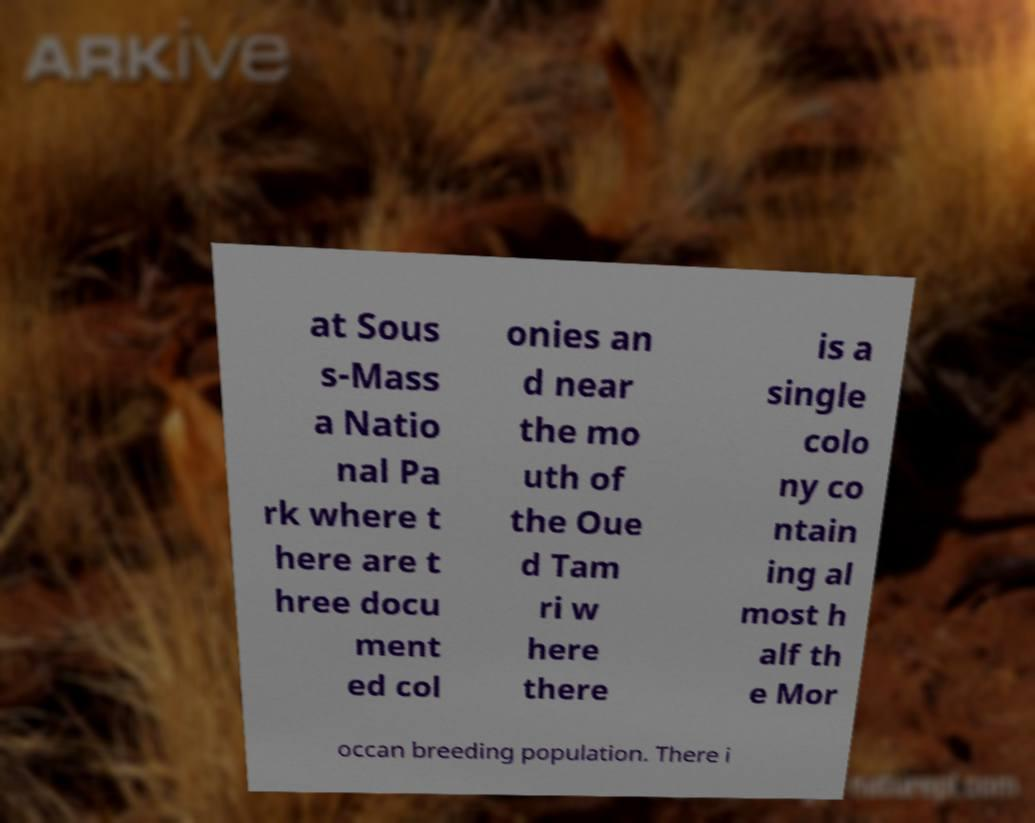For documentation purposes, I need the text within this image transcribed. Could you provide that? at Sous s-Mass a Natio nal Pa rk where t here are t hree docu ment ed col onies an d near the mo uth of the Oue d Tam ri w here there is a single colo ny co ntain ing al most h alf th e Mor occan breeding population. There i 